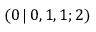<formula> <loc_0><loc_0><loc_500><loc_500>( 0 \, | \, 0 , 1 , 1 ; 2 )</formula> 